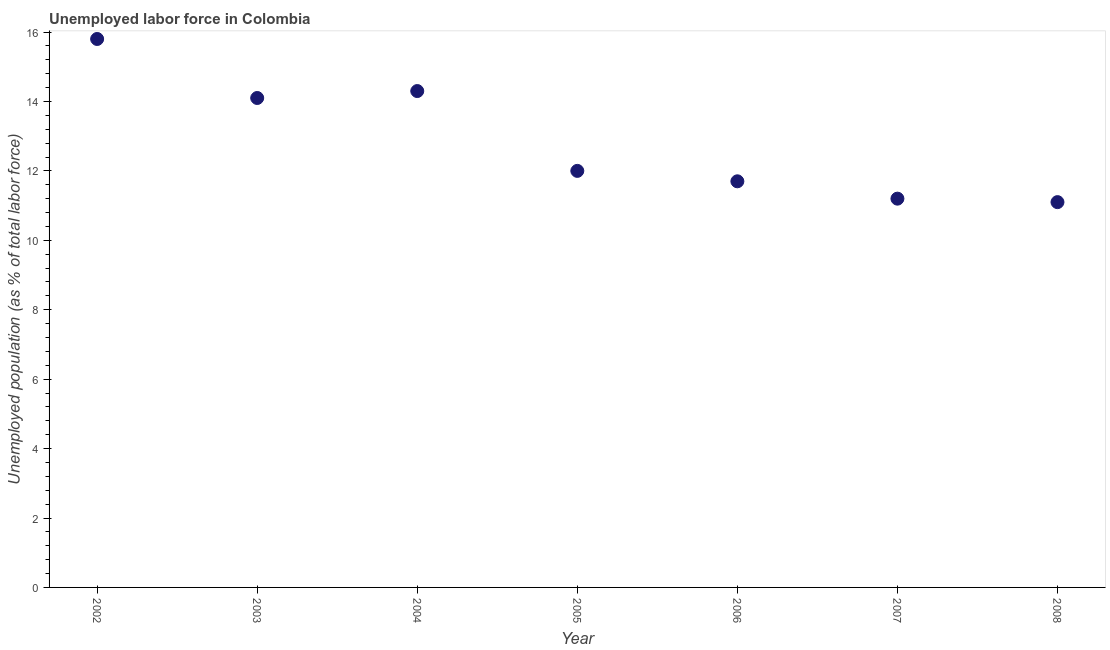What is the total unemployed population in 2007?
Provide a short and direct response. 11.2. Across all years, what is the maximum total unemployed population?
Offer a very short reply. 15.8. Across all years, what is the minimum total unemployed population?
Your response must be concise. 11.1. In which year was the total unemployed population maximum?
Make the answer very short. 2002. What is the sum of the total unemployed population?
Give a very brief answer. 90.2. What is the difference between the total unemployed population in 2004 and 2007?
Offer a very short reply. 3.1. What is the average total unemployed population per year?
Offer a terse response. 12.89. What is the median total unemployed population?
Offer a very short reply. 12. In how many years, is the total unemployed population greater than 0.4 %?
Your response must be concise. 7. What is the ratio of the total unemployed population in 2002 to that in 2007?
Provide a succinct answer. 1.41. Is the sum of the total unemployed population in 2006 and 2007 greater than the maximum total unemployed population across all years?
Ensure brevity in your answer.  Yes. What is the difference between the highest and the lowest total unemployed population?
Offer a very short reply. 4.7. In how many years, is the total unemployed population greater than the average total unemployed population taken over all years?
Offer a very short reply. 3. Does the total unemployed population monotonically increase over the years?
Your response must be concise. No. How many dotlines are there?
Ensure brevity in your answer.  1. How many years are there in the graph?
Give a very brief answer. 7. What is the difference between two consecutive major ticks on the Y-axis?
Your answer should be compact. 2. Does the graph contain any zero values?
Your answer should be compact. No. What is the title of the graph?
Provide a succinct answer. Unemployed labor force in Colombia. What is the label or title of the X-axis?
Provide a succinct answer. Year. What is the label or title of the Y-axis?
Provide a short and direct response. Unemployed population (as % of total labor force). What is the Unemployed population (as % of total labor force) in 2002?
Give a very brief answer. 15.8. What is the Unemployed population (as % of total labor force) in 2003?
Your answer should be very brief. 14.1. What is the Unemployed population (as % of total labor force) in 2004?
Keep it short and to the point. 14.3. What is the Unemployed population (as % of total labor force) in 2005?
Your response must be concise. 12. What is the Unemployed population (as % of total labor force) in 2006?
Your answer should be compact. 11.7. What is the Unemployed population (as % of total labor force) in 2007?
Your response must be concise. 11.2. What is the Unemployed population (as % of total labor force) in 2008?
Offer a very short reply. 11.1. What is the difference between the Unemployed population (as % of total labor force) in 2002 and 2005?
Offer a terse response. 3.8. What is the difference between the Unemployed population (as % of total labor force) in 2002 and 2007?
Provide a succinct answer. 4.6. What is the difference between the Unemployed population (as % of total labor force) in 2003 and 2004?
Offer a very short reply. -0.2. What is the difference between the Unemployed population (as % of total labor force) in 2003 and 2007?
Give a very brief answer. 2.9. What is the difference between the Unemployed population (as % of total labor force) in 2003 and 2008?
Offer a very short reply. 3. What is the difference between the Unemployed population (as % of total labor force) in 2004 and 2005?
Provide a succinct answer. 2.3. What is the difference between the Unemployed population (as % of total labor force) in 2007 and 2008?
Your response must be concise. 0.1. What is the ratio of the Unemployed population (as % of total labor force) in 2002 to that in 2003?
Ensure brevity in your answer.  1.12. What is the ratio of the Unemployed population (as % of total labor force) in 2002 to that in 2004?
Offer a very short reply. 1.1. What is the ratio of the Unemployed population (as % of total labor force) in 2002 to that in 2005?
Ensure brevity in your answer.  1.32. What is the ratio of the Unemployed population (as % of total labor force) in 2002 to that in 2006?
Provide a succinct answer. 1.35. What is the ratio of the Unemployed population (as % of total labor force) in 2002 to that in 2007?
Offer a very short reply. 1.41. What is the ratio of the Unemployed population (as % of total labor force) in 2002 to that in 2008?
Make the answer very short. 1.42. What is the ratio of the Unemployed population (as % of total labor force) in 2003 to that in 2005?
Provide a succinct answer. 1.18. What is the ratio of the Unemployed population (as % of total labor force) in 2003 to that in 2006?
Ensure brevity in your answer.  1.21. What is the ratio of the Unemployed population (as % of total labor force) in 2003 to that in 2007?
Offer a very short reply. 1.26. What is the ratio of the Unemployed population (as % of total labor force) in 2003 to that in 2008?
Provide a short and direct response. 1.27. What is the ratio of the Unemployed population (as % of total labor force) in 2004 to that in 2005?
Keep it short and to the point. 1.19. What is the ratio of the Unemployed population (as % of total labor force) in 2004 to that in 2006?
Make the answer very short. 1.22. What is the ratio of the Unemployed population (as % of total labor force) in 2004 to that in 2007?
Keep it short and to the point. 1.28. What is the ratio of the Unemployed population (as % of total labor force) in 2004 to that in 2008?
Offer a very short reply. 1.29. What is the ratio of the Unemployed population (as % of total labor force) in 2005 to that in 2007?
Offer a very short reply. 1.07. What is the ratio of the Unemployed population (as % of total labor force) in 2005 to that in 2008?
Your answer should be very brief. 1.08. What is the ratio of the Unemployed population (as % of total labor force) in 2006 to that in 2007?
Keep it short and to the point. 1.04. What is the ratio of the Unemployed population (as % of total labor force) in 2006 to that in 2008?
Offer a very short reply. 1.05. 